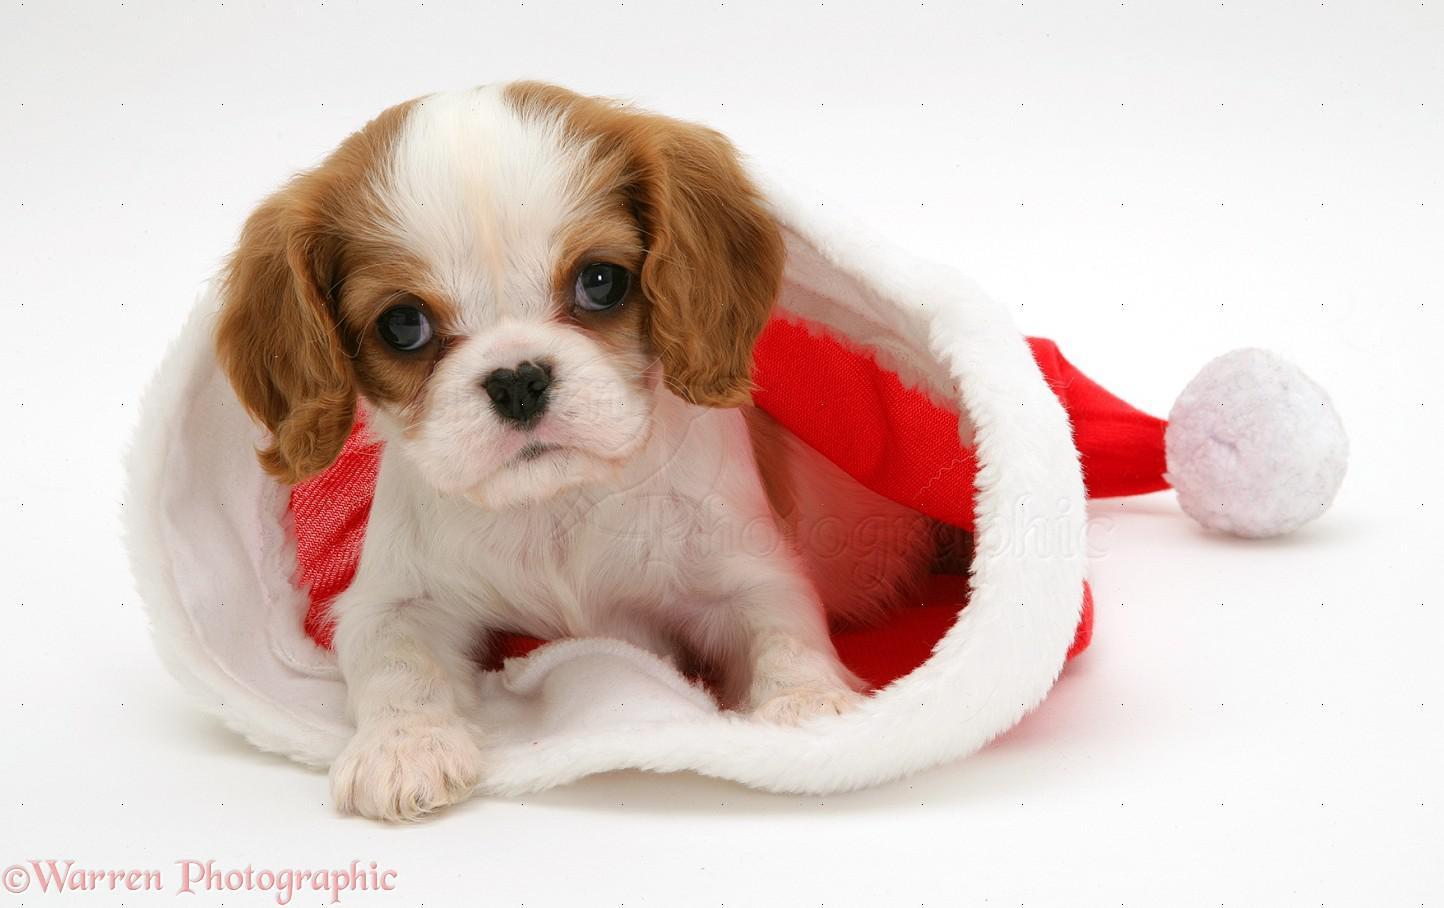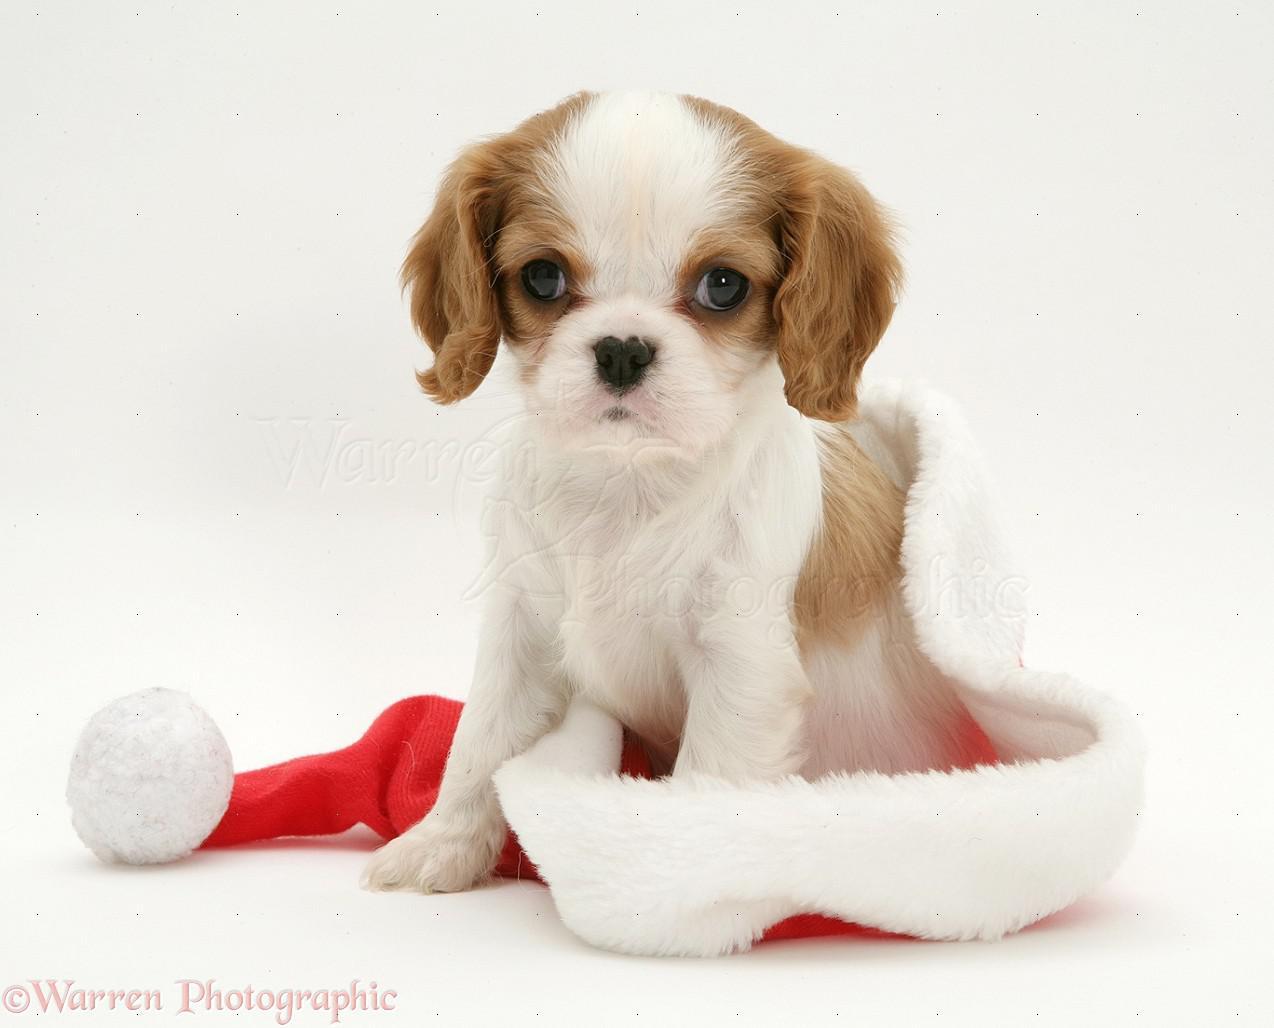The first image is the image on the left, the second image is the image on the right. Considering the images on both sides, is "An image shows one puppy in a Santa hat and another puppy behind the hat." valid? Answer yes or no. No. The first image is the image on the left, the second image is the image on the right. Evaluate the accuracy of this statement regarding the images: "The left image shows a black, white and brown dog inside a santa hat and a brown and white dog next to it". Is it true? Answer yes or no. No. 